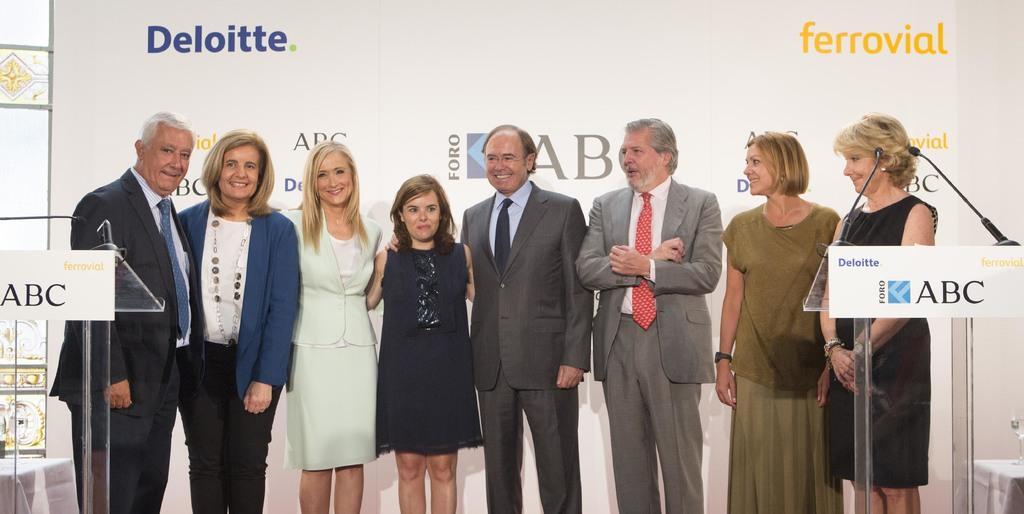Could you give a brief overview of what you see in this image? Here we can see few persons standing on the stage and on the left and right there is a podium with microphones on it,table with glasses on it. In the background there is a hoarding and a wall. 